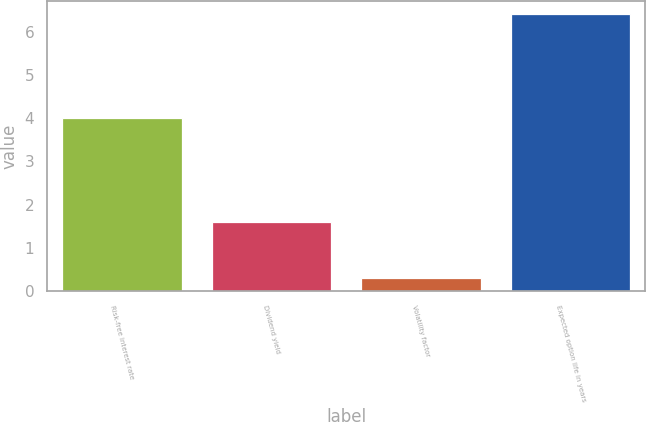Convert chart to OTSL. <chart><loc_0><loc_0><loc_500><loc_500><bar_chart><fcel>Risk-free interest rate<fcel>Dividend yield<fcel>Volatility factor<fcel>Expected option life in years<nl><fcel>4<fcel>1.6<fcel>0.31<fcel>6.4<nl></chart> 